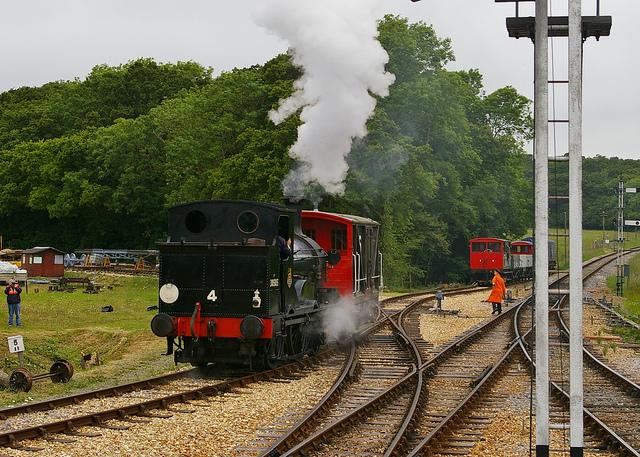Why is the man wearing an orange jacket? visibility 